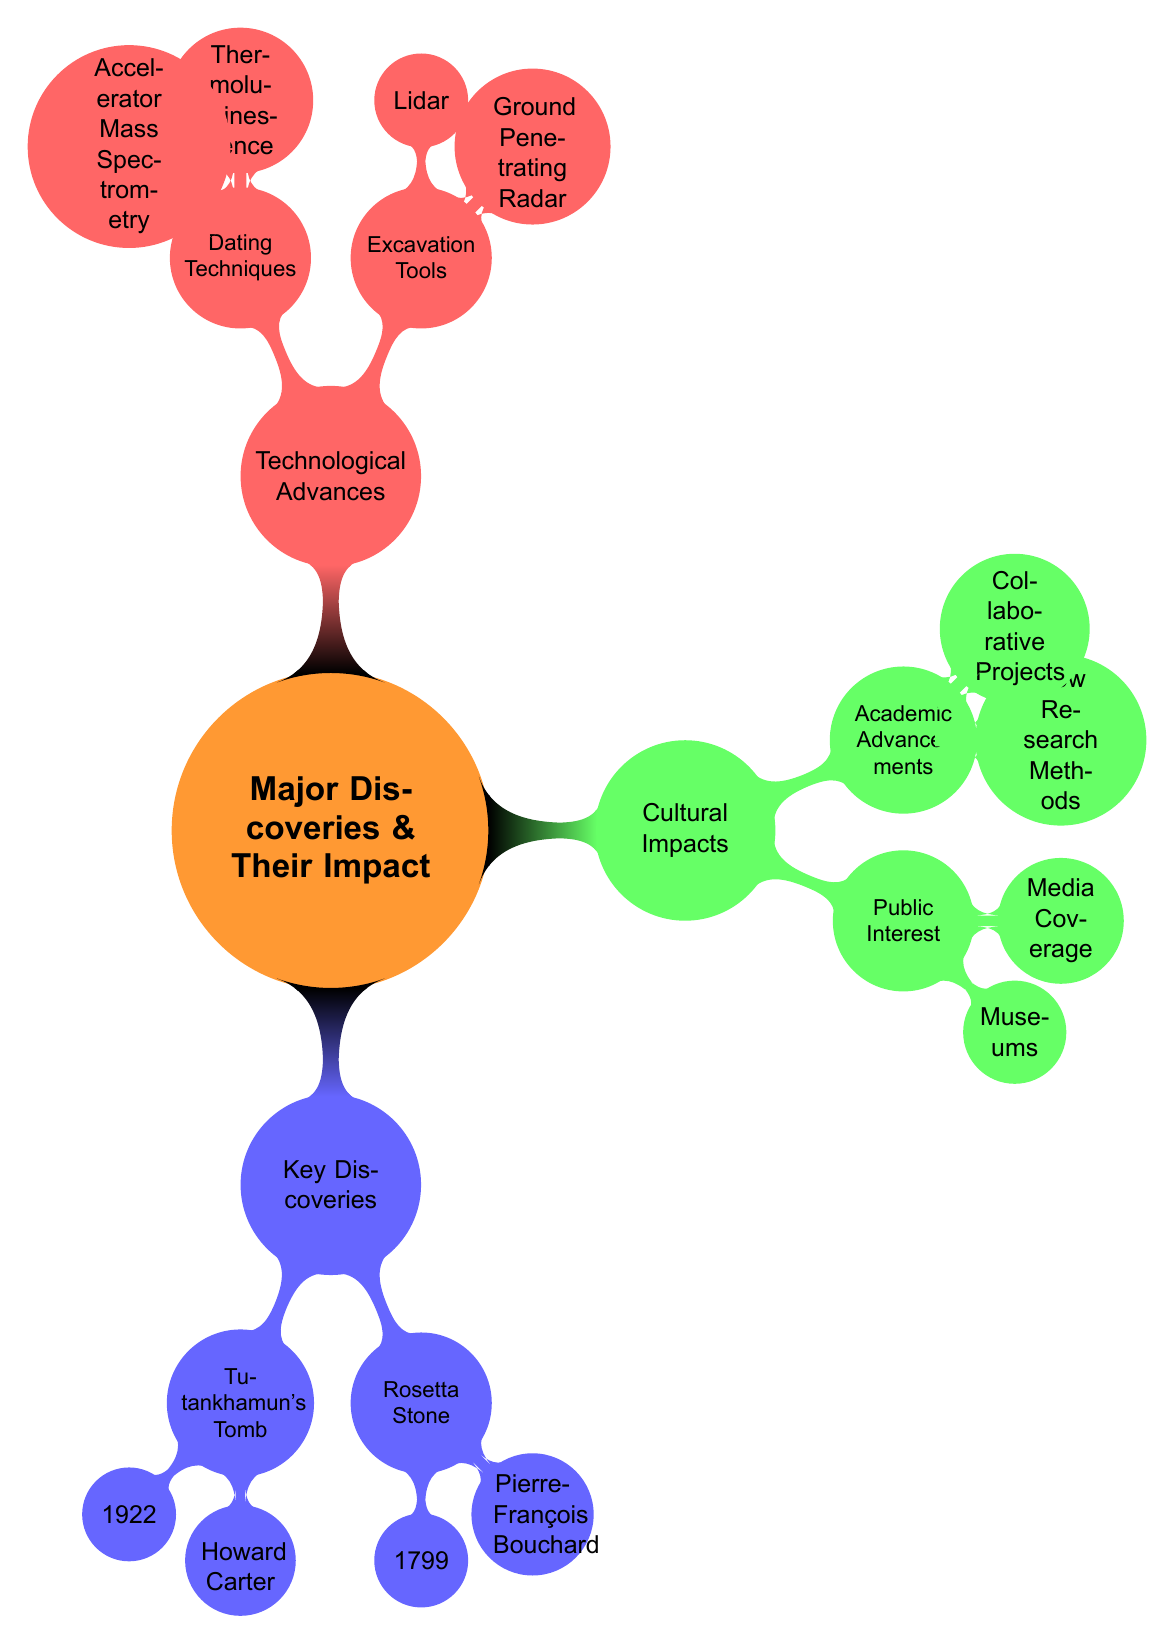What year was Tutankhamun's Tomb discovered? The diagram lists the discovery of Tutankhamun's Tomb under the "Key Discoveries" section, where it states the year of discovery as 1922.
Answer: 1922 Who discovered the Rosetta Stone? Under the "Key Discoveries" section, the Rosetta Stone is associated with Pierre-François Bouchard as the discoverer.
Answer: Pierre-François Bouchard What are two excavation tools mentioned? The "Technological Advances" section includes a child node under "Excavation Tools," listing Ground Penetrating Radar and Lidar as examples.
Answer: Ground Penetrating Radar, Lidar What impact did the discovery of Tutankhamun's Tomb have on public interest? The diagram shows that one of the impacts was an increased public interest in Egyptology, as listed under its impacts in the Key Discoveries section.
Answer: Boosted public interest in Egyptology How are cultural impacts divided in the diagram? The "Cultural Impacts" node is divided into two child nodes: "Public Interest" and "Academic Advancements," which reflect different aspects of cultural impacts.
Answer: Public Interest and Academic Advancements Which dating technique is listed first in the diagram? In the "Dating Techniques" section under "Technological Advances," Thermoluminescence Dating is listed first according to the layout of the diagram.
Answer: Thermoluminescence Dating How do academic advancements influence archaeology? The diagram shows that academic advancements consist of new research methods and collaborative projects, implying that they enhance the approach and understanding in archaeology.
Answer: New Research Methods and Collaborative Projects What significant cultural impact is associated with museums? The "Public Interest" section of the "Cultural Impacts" highlights "Museums Exhibits," indicating a significant cultural impact.
Answer: Museums Exhibits 